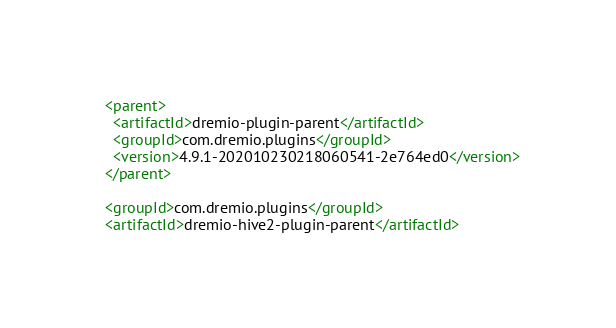<code> <loc_0><loc_0><loc_500><loc_500><_XML_>  <parent>
    <artifactId>dremio-plugin-parent</artifactId>
    <groupId>com.dremio.plugins</groupId>
    <version>4.9.1-202010230218060541-2e764ed0</version>
  </parent>

  <groupId>com.dremio.plugins</groupId>
  <artifactId>dremio-hive2-plugin-parent</artifactId></code> 